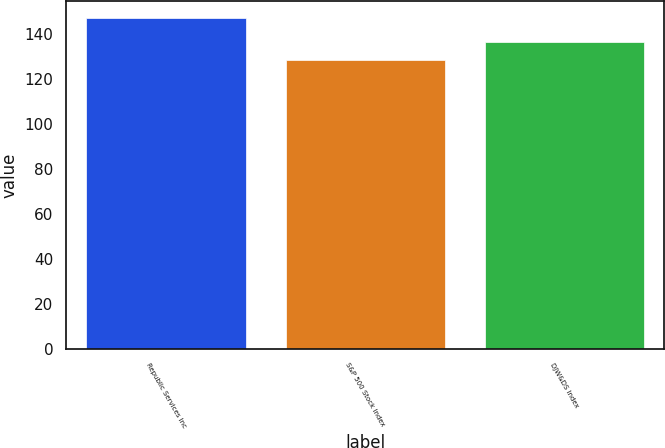Convert chart to OTSL. <chart><loc_0><loc_0><loc_500><loc_500><bar_chart><fcel>Republic Services Inc<fcel>S&P 500 Stock Index<fcel>DJW&DS Index<nl><fcel>146.98<fcel>128.16<fcel>136.29<nl></chart> 